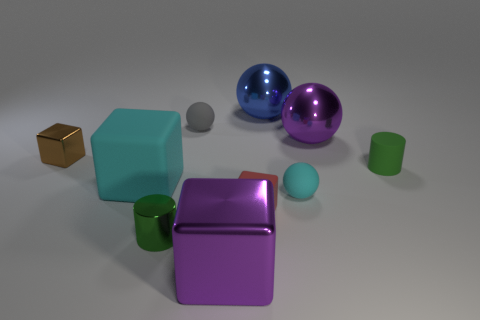Subtract all blocks. How many objects are left? 6 Subtract all small red cylinders. Subtract all small red cubes. How many objects are left? 9 Add 1 brown shiny objects. How many brown shiny objects are left? 2 Add 4 big objects. How many big objects exist? 8 Subtract 1 purple cubes. How many objects are left? 9 